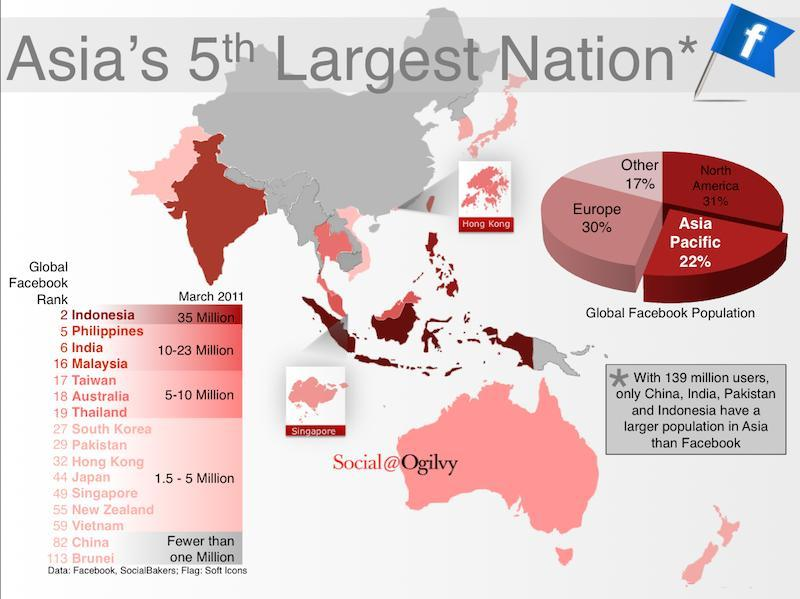What percentage of the Asia Pacific and North America constitutes the global Facebook Population, taken together?
Answer the question with a short phrase. 53% What percentage of the Other and Europe constitutes the global Facebook Population, taken together? 47% What percentage of the Asia Pacific and Europe constitutes the global Facebook Population, taken together? 52% How many global Facebook ranks mentioned in this infographic? 16 